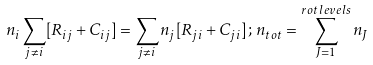Convert formula to latex. <formula><loc_0><loc_0><loc_500><loc_500>n _ { i } \sum _ { j \neq i } [ R _ { i j } + C _ { i j } ] = \sum _ { j \neq i } n _ { j } [ R _ { j i } + C _ { j i } ] \, ; \, n _ { t o t } = \sum _ { J = 1 } ^ { r o t \, l e v e l s } n _ { J }</formula> 